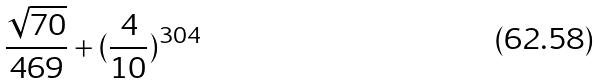<formula> <loc_0><loc_0><loc_500><loc_500>\frac { \sqrt { 7 0 } } { 4 6 9 } + ( \frac { 4 } { 1 0 } ) ^ { 3 0 4 }</formula> 